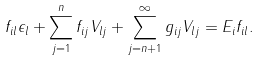Convert formula to latex. <formula><loc_0><loc_0><loc_500><loc_500>f _ { i l } \epsilon _ { l } + \sum _ { j = 1 } ^ { n } f _ { i j } V _ { l j } + \sum _ { j = n + 1 } ^ { \infty } g _ { i j } V _ { l j } = E _ { i } f _ { i l } .</formula> 